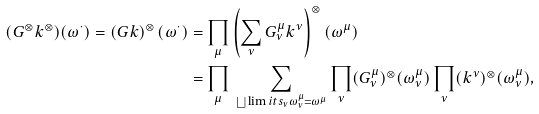<formula> <loc_0><loc_0><loc_500><loc_500>( G ^ { \otimes } k ^ { \otimes } ) ( \omega ^ { \cdot } ) = \left ( G k \right ) ^ { \otimes } ( \omega ^ { \cdot } ) & = \prod _ { \mu } \left ( \sum _ { \nu } G _ { \nu } ^ { \mu } k ^ { \nu } \right ) ^ { \otimes } ( \omega ^ { \mu } ) \\ & = \prod _ { \mu } \, \sum _ { \bigsqcup \lim i t s _ { \nu } \omega _ { \nu } ^ { \mu } = \omega ^ { \mu } } \prod _ { \nu } ( G _ { \nu } ^ { \mu } ) ^ { \otimes } ( \omega _ { \nu } ^ { \mu } ) \prod _ { \nu } ( k ^ { \nu } ) ^ { \otimes } ( \omega _ { \nu } ^ { \mu } ) ,</formula> 